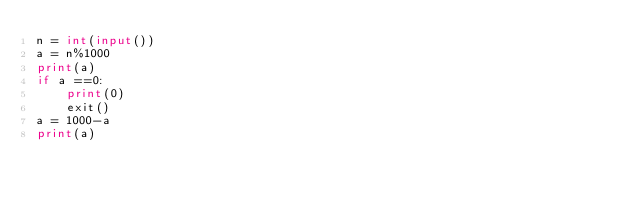Convert code to text. <code><loc_0><loc_0><loc_500><loc_500><_Python_>n = int(input())
a = n%1000
print(a)
if a ==0:
    print(0)
    exit()
a = 1000-a
print(a)</code> 